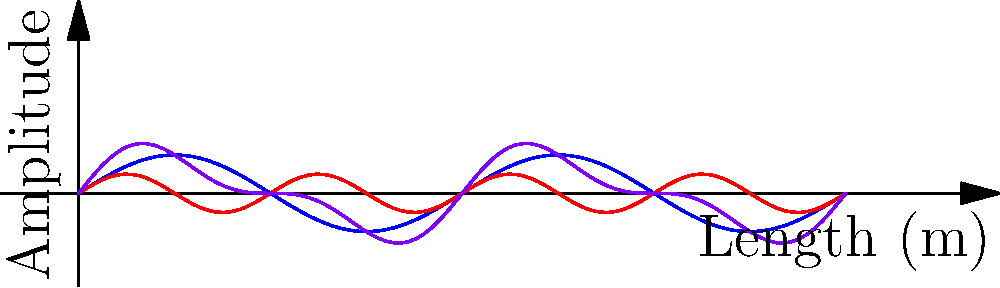In St. Paul's Cathedral, you observe sound waves creating a resonance pattern. The graph shows the fundamental frequency (blue) and the first harmonic (red) of the sound waves, as well as their combined effect (purple). If the length of the cathedral nave is 10 meters, what is the wavelength of the fundamental frequency? To solve this problem, let's follow these steps:

1. Recall that for standing waves in a closed pipe (which we can consider the cathedral nave to be), the fundamental frequency has nodes at both ends and one antinode in the middle.

2. This means that the length of the nave represents half of the wavelength for the fundamental frequency.

3. From the graph, we can see that the blue line (fundamental frequency) completes exactly one full cycle over the 10-meter length.

4. This confirms that the 10-meter length of the nave is indeed half of the wavelength.

5. Therefore, if 10 meters is half the wavelength, the full wavelength must be twice this length.

6. So, the wavelength of the fundamental frequency is: $\lambda = 2 \times 10 = 20$ meters.
Answer: 20 meters 